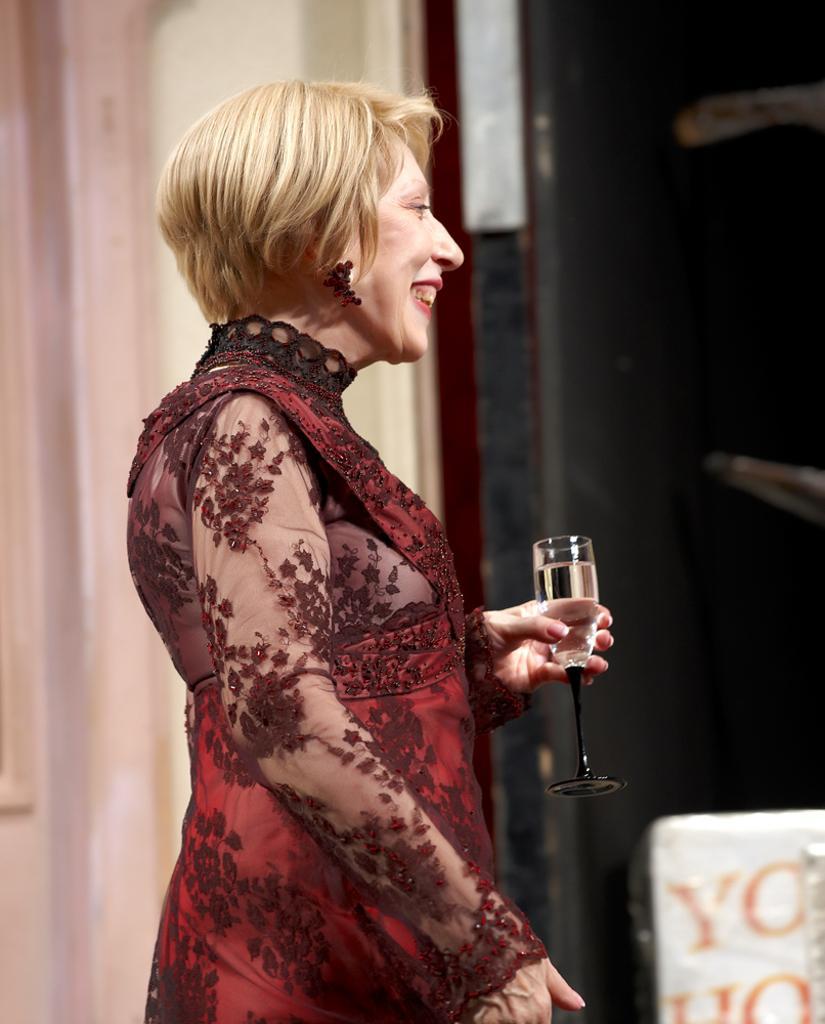Describe this image in one or two sentences. There is a woman wearing red color costume holding wine glass with wine. 